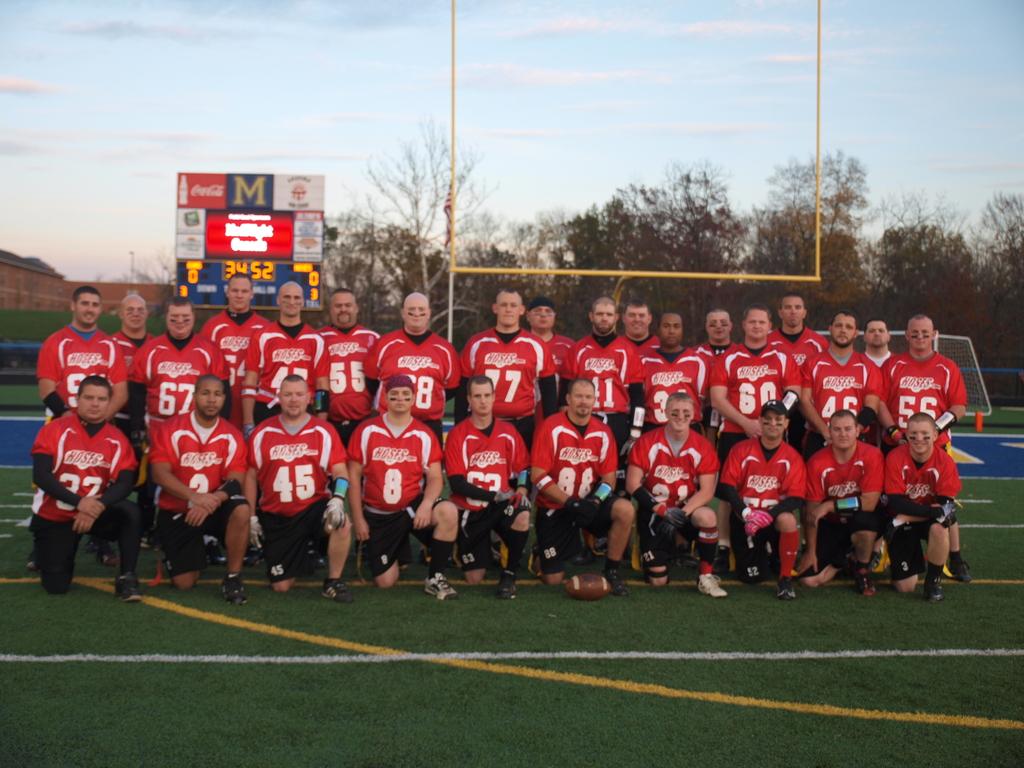What numbers can you clearly see in the bottom row of players?
Provide a short and direct response. 45, 8, 88. What is the large orange letter on the signboard in the back?
Provide a succinct answer. M. 